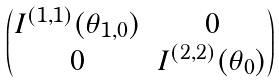Convert formula to latex. <formula><loc_0><loc_0><loc_500><loc_500>\begin{pmatrix} I ^ { ( 1 , 1 ) } ( \theta _ { 1 , 0 } ) & 0 \\ 0 & I ^ { ( 2 , 2 ) } ( \theta _ { 0 } ) \end{pmatrix}</formula> 